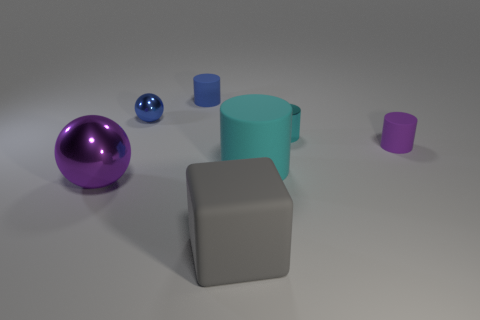Do the tiny blue object to the right of the small blue metal sphere and the large cyan object have the same shape?
Provide a succinct answer. Yes. What is the color of the shiny object that is on the left side of the blue shiny thing?
Offer a terse response. Purple. How many other things are the same size as the purple cylinder?
Provide a short and direct response. 3. Is there anything else that has the same shape as the large gray object?
Your answer should be very brief. No. Are there an equal number of purple rubber things to the left of the metal cylinder and small yellow matte things?
Provide a succinct answer. Yes. What number of large objects are made of the same material as the big cyan cylinder?
Keep it short and to the point. 1. What color is the other sphere that is the same material as the big purple ball?
Provide a succinct answer. Blue. Do the tiny blue rubber object and the big cyan rubber thing have the same shape?
Ensure brevity in your answer.  Yes. There is a small metal thing that is on the right side of the matte cylinder behind the small blue shiny sphere; is there a cyan thing that is to the left of it?
Ensure brevity in your answer.  Yes. How many shiny cylinders have the same color as the big matte cylinder?
Make the answer very short. 1. 